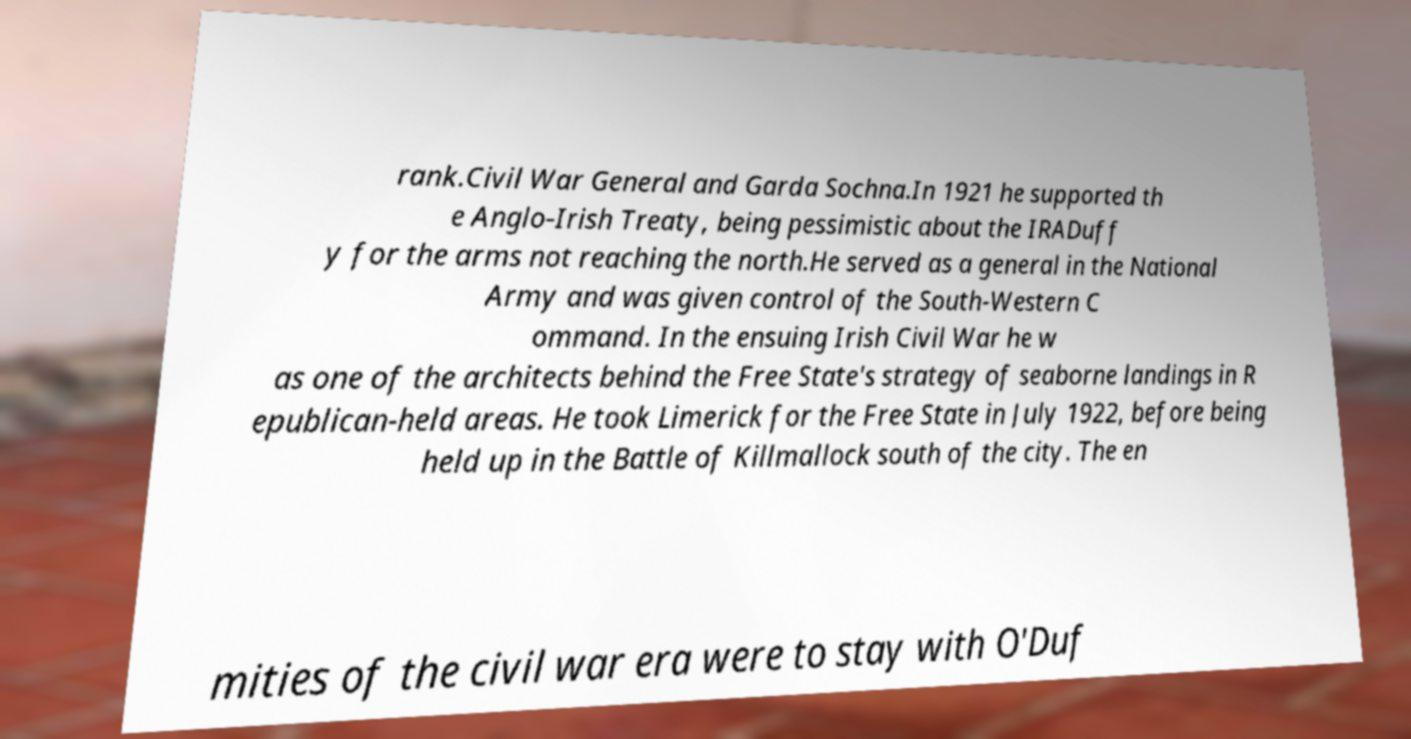For documentation purposes, I need the text within this image transcribed. Could you provide that? rank.Civil War General and Garda Sochna.In 1921 he supported th e Anglo-Irish Treaty, being pessimistic about the IRADuff y for the arms not reaching the north.He served as a general in the National Army and was given control of the South-Western C ommand. In the ensuing Irish Civil War he w as one of the architects behind the Free State's strategy of seaborne landings in R epublican-held areas. He took Limerick for the Free State in July 1922, before being held up in the Battle of Killmallock south of the city. The en mities of the civil war era were to stay with O'Duf 